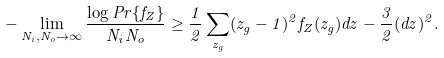<formula> <loc_0><loc_0><loc_500><loc_500>- \lim _ { N _ { i } , N _ { o } \to \infty } \frac { \log P r \{ f _ { Z } \} } { N _ { i } N _ { o } } \geq \frac { 1 } { 2 } \sum _ { z _ { g } } ( z _ { g } - 1 ) ^ { 2 } f _ { Z } ( z _ { g } ) d z - \frac { 3 } { 2 } ( d z ) ^ { 2 } .</formula> 